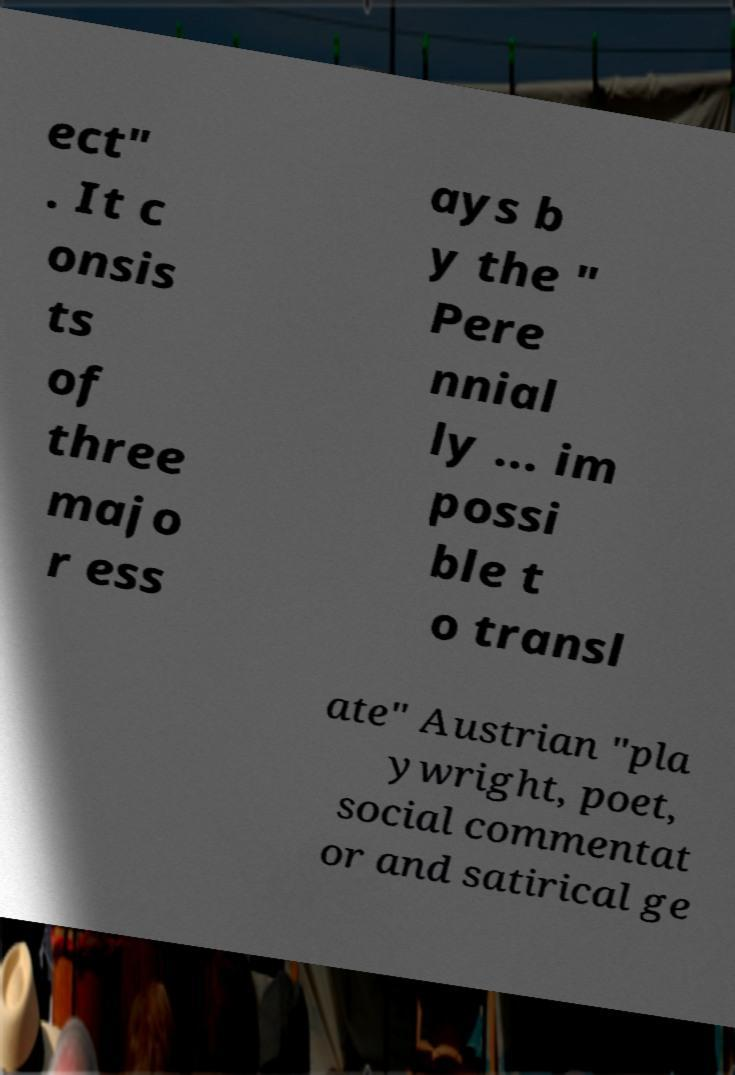Could you assist in decoding the text presented in this image and type it out clearly? ect" . It c onsis ts of three majo r ess ays b y the " Pere nnial ly ... im possi ble t o transl ate" Austrian "pla ywright, poet, social commentat or and satirical ge 